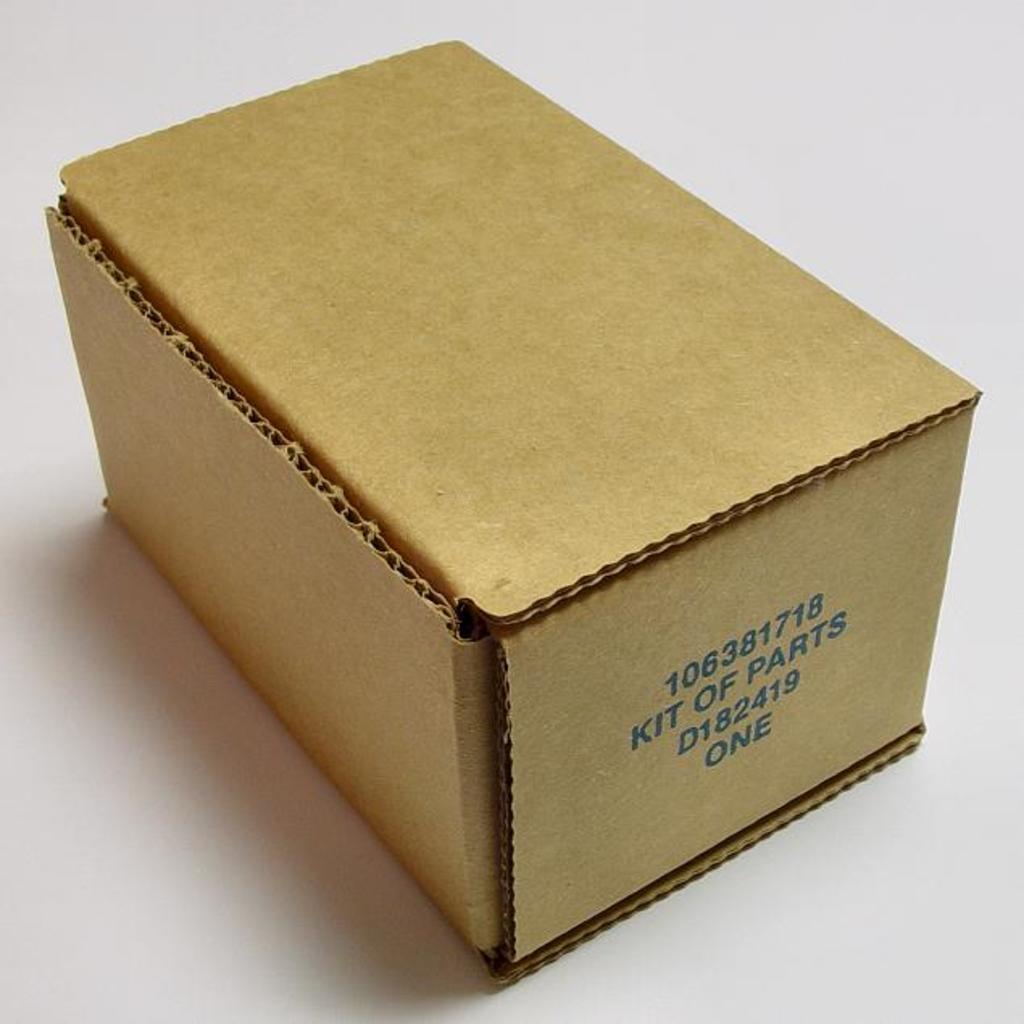What type of parts are inside of this?
Provide a short and direct response. Kit of parts. 